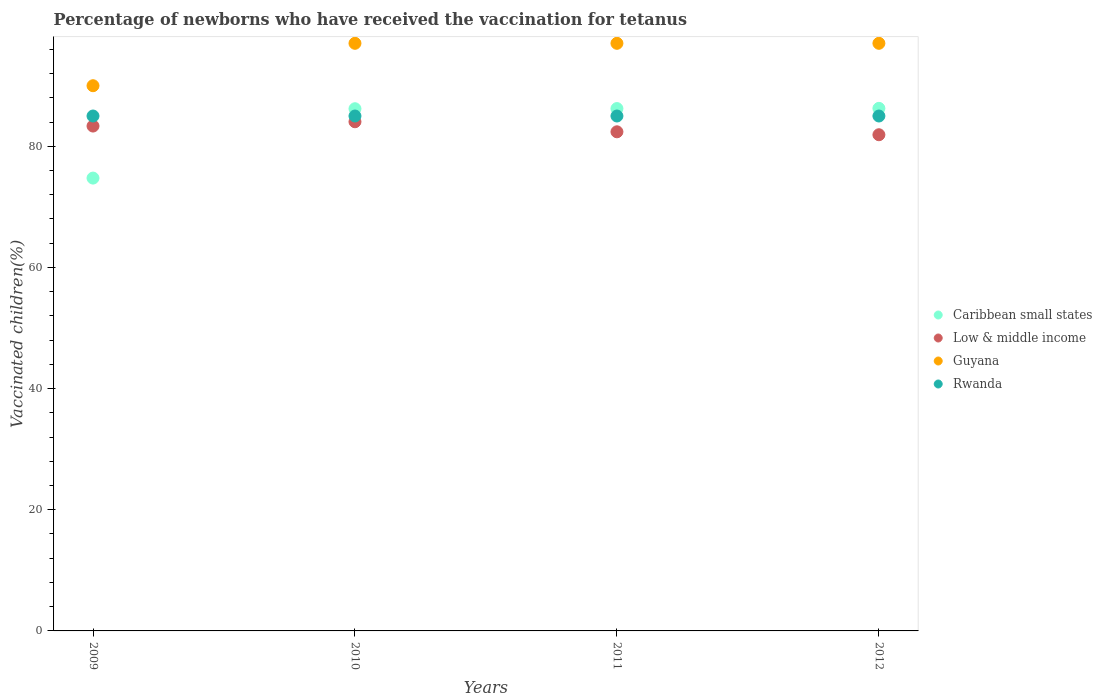Is the number of dotlines equal to the number of legend labels?
Your answer should be compact. Yes. What is the percentage of vaccinated children in Low & middle income in 2011?
Your answer should be very brief. 82.39. Across all years, what is the maximum percentage of vaccinated children in Guyana?
Keep it short and to the point. 97. Across all years, what is the minimum percentage of vaccinated children in Rwanda?
Give a very brief answer. 85. In which year was the percentage of vaccinated children in Caribbean small states maximum?
Your answer should be compact. 2012. What is the total percentage of vaccinated children in Caribbean small states in the graph?
Give a very brief answer. 333.44. What is the difference between the percentage of vaccinated children in Caribbean small states in 2009 and that in 2011?
Give a very brief answer. -11.47. What is the difference between the percentage of vaccinated children in Low & middle income in 2010 and the percentage of vaccinated children in Rwanda in 2009?
Keep it short and to the point. -0.95. What is the average percentage of vaccinated children in Caribbean small states per year?
Your answer should be compact. 83.36. In the year 2009, what is the difference between the percentage of vaccinated children in Rwanda and percentage of vaccinated children in Low & middle income?
Make the answer very short. 1.66. In how many years, is the percentage of vaccinated children in Guyana greater than 92 %?
Offer a terse response. 3. What is the ratio of the percentage of vaccinated children in Low & middle income in 2010 to that in 2012?
Provide a short and direct response. 1.03. Is the difference between the percentage of vaccinated children in Rwanda in 2010 and 2012 greater than the difference between the percentage of vaccinated children in Low & middle income in 2010 and 2012?
Your answer should be very brief. No. What is the difference between the highest and the second highest percentage of vaccinated children in Low & middle income?
Make the answer very short. 0.71. In how many years, is the percentage of vaccinated children in Rwanda greater than the average percentage of vaccinated children in Rwanda taken over all years?
Offer a very short reply. 0. Is the sum of the percentage of vaccinated children in Rwanda in 2009 and 2011 greater than the maximum percentage of vaccinated children in Low & middle income across all years?
Offer a terse response. Yes. Is it the case that in every year, the sum of the percentage of vaccinated children in Caribbean small states and percentage of vaccinated children in Rwanda  is greater than the sum of percentage of vaccinated children in Guyana and percentage of vaccinated children in Low & middle income?
Ensure brevity in your answer.  No. Is the percentage of vaccinated children in Low & middle income strictly greater than the percentage of vaccinated children in Rwanda over the years?
Keep it short and to the point. No. How many years are there in the graph?
Your response must be concise. 4. Where does the legend appear in the graph?
Your response must be concise. Center right. What is the title of the graph?
Your answer should be very brief. Percentage of newborns who have received the vaccination for tetanus. Does "Cambodia" appear as one of the legend labels in the graph?
Offer a very short reply. No. What is the label or title of the X-axis?
Offer a very short reply. Years. What is the label or title of the Y-axis?
Offer a very short reply. Vaccinated children(%). What is the Vaccinated children(%) in Caribbean small states in 2009?
Ensure brevity in your answer.  74.75. What is the Vaccinated children(%) in Low & middle income in 2009?
Offer a very short reply. 83.34. What is the Vaccinated children(%) of Guyana in 2009?
Make the answer very short. 90. What is the Vaccinated children(%) in Rwanda in 2009?
Your response must be concise. 85. What is the Vaccinated children(%) in Caribbean small states in 2010?
Give a very brief answer. 86.2. What is the Vaccinated children(%) of Low & middle income in 2010?
Make the answer very short. 84.05. What is the Vaccinated children(%) of Guyana in 2010?
Your answer should be very brief. 97. What is the Vaccinated children(%) in Caribbean small states in 2011?
Your answer should be compact. 86.23. What is the Vaccinated children(%) of Low & middle income in 2011?
Your response must be concise. 82.39. What is the Vaccinated children(%) in Guyana in 2011?
Ensure brevity in your answer.  97. What is the Vaccinated children(%) of Caribbean small states in 2012?
Your answer should be compact. 86.26. What is the Vaccinated children(%) of Low & middle income in 2012?
Ensure brevity in your answer.  81.91. What is the Vaccinated children(%) of Guyana in 2012?
Provide a short and direct response. 97. What is the Vaccinated children(%) of Rwanda in 2012?
Keep it short and to the point. 85. Across all years, what is the maximum Vaccinated children(%) in Caribbean small states?
Provide a succinct answer. 86.26. Across all years, what is the maximum Vaccinated children(%) in Low & middle income?
Make the answer very short. 84.05. Across all years, what is the maximum Vaccinated children(%) in Guyana?
Your answer should be compact. 97. Across all years, what is the maximum Vaccinated children(%) in Rwanda?
Provide a succinct answer. 85. Across all years, what is the minimum Vaccinated children(%) of Caribbean small states?
Your answer should be compact. 74.75. Across all years, what is the minimum Vaccinated children(%) in Low & middle income?
Provide a short and direct response. 81.91. Across all years, what is the minimum Vaccinated children(%) in Rwanda?
Your answer should be very brief. 85. What is the total Vaccinated children(%) of Caribbean small states in the graph?
Offer a very short reply. 333.44. What is the total Vaccinated children(%) in Low & middle income in the graph?
Give a very brief answer. 331.69. What is the total Vaccinated children(%) of Guyana in the graph?
Ensure brevity in your answer.  381. What is the total Vaccinated children(%) in Rwanda in the graph?
Give a very brief answer. 340. What is the difference between the Vaccinated children(%) in Caribbean small states in 2009 and that in 2010?
Your response must be concise. -11.45. What is the difference between the Vaccinated children(%) in Low & middle income in 2009 and that in 2010?
Your answer should be very brief. -0.71. What is the difference between the Vaccinated children(%) in Guyana in 2009 and that in 2010?
Keep it short and to the point. -7. What is the difference between the Vaccinated children(%) of Rwanda in 2009 and that in 2010?
Provide a short and direct response. 0. What is the difference between the Vaccinated children(%) of Caribbean small states in 2009 and that in 2011?
Your response must be concise. -11.47. What is the difference between the Vaccinated children(%) of Low & middle income in 2009 and that in 2011?
Provide a short and direct response. 0.95. What is the difference between the Vaccinated children(%) of Guyana in 2009 and that in 2011?
Your response must be concise. -7. What is the difference between the Vaccinated children(%) in Rwanda in 2009 and that in 2011?
Ensure brevity in your answer.  0. What is the difference between the Vaccinated children(%) in Caribbean small states in 2009 and that in 2012?
Provide a short and direct response. -11.51. What is the difference between the Vaccinated children(%) in Low & middle income in 2009 and that in 2012?
Make the answer very short. 1.43. What is the difference between the Vaccinated children(%) in Guyana in 2009 and that in 2012?
Keep it short and to the point. -7. What is the difference between the Vaccinated children(%) in Caribbean small states in 2010 and that in 2011?
Keep it short and to the point. -0.03. What is the difference between the Vaccinated children(%) of Low & middle income in 2010 and that in 2011?
Ensure brevity in your answer.  1.66. What is the difference between the Vaccinated children(%) of Guyana in 2010 and that in 2011?
Make the answer very short. 0. What is the difference between the Vaccinated children(%) in Rwanda in 2010 and that in 2011?
Give a very brief answer. 0. What is the difference between the Vaccinated children(%) in Caribbean small states in 2010 and that in 2012?
Offer a terse response. -0.06. What is the difference between the Vaccinated children(%) in Low & middle income in 2010 and that in 2012?
Your answer should be very brief. 2.14. What is the difference between the Vaccinated children(%) in Rwanda in 2010 and that in 2012?
Provide a succinct answer. 0. What is the difference between the Vaccinated children(%) of Caribbean small states in 2011 and that in 2012?
Your answer should be compact. -0.03. What is the difference between the Vaccinated children(%) of Low & middle income in 2011 and that in 2012?
Keep it short and to the point. 0.48. What is the difference between the Vaccinated children(%) of Guyana in 2011 and that in 2012?
Offer a very short reply. 0. What is the difference between the Vaccinated children(%) of Rwanda in 2011 and that in 2012?
Keep it short and to the point. 0. What is the difference between the Vaccinated children(%) of Caribbean small states in 2009 and the Vaccinated children(%) of Low & middle income in 2010?
Provide a short and direct response. -9.3. What is the difference between the Vaccinated children(%) of Caribbean small states in 2009 and the Vaccinated children(%) of Guyana in 2010?
Offer a terse response. -22.25. What is the difference between the Vaccinated children(%) of Caribbean small states in 2009 and the Vaccinated children(%) of Rwanda in 2010?
Your answer should be compact. -10.25. What is the difference between the Vaccinated children(%) of Low & middle income in 2009 and the Vaccinated children(%) of Guyana in 2010?
Offer a very short reply. -13.66. What is the difference between the Vaccinated children(%) of Low & middle income in 2009 and the Vaccinated children(%) of Rwanda in 2010?
Offer a very short reply. -1.66. What is the difference between the Vaccinated children(%) in Guyana in 2009 and the Vaccinated children(%) in Rwanda in 2010?
Keep it short and to the point. 5. What is the difference between the Vaccinated children(%) of Caribbean small states in 2009 and the Vaccinated children(%) of Low & middle income in 2011?
Your response must be concise. -7.64. What is the difference between the Vaccinated children(%) of Caribbean small states in 2009 and the Vaccinated children(%) of Guyana in 2011?
Your answer should be compact. -22.25. What is the difference between the Vaccinated children(%) in Caribbean small states in 2009 and the Vaccinated children(%) in Rwanda in 2011?
Your answer should be very brief. -10.25. What is the difference between the Vaccinated children(%) of Low & middle income in 2009 and the Vaccinated children(%) of Guyana in 2011?
Provide a succinct answer. -13.66. What is the difference between the Vaccinated children(%) of Low & middle income in 2009 and the Vaccinated children(%) of Rwanda in 2011?
Your answer should be compact. -1.66. What is the difference between the Vaccinated children(%) of Caribbean small states in 2009 and the Vaccinated children(%) of Low & middle income in 2012?
Your response must be concise. -7.16. What is the difference between the Vaccinated children(%) of Caribbean small states in 2009 and the Vaccinated children(%) of Guyana in 2012?
Your answer should be very brief. -22.25. What is the difference between the Vaccinated children(%) in Caribbean small states in 2009 and the Vaccinated children(%) in Rwanda in 2012?
Provide a succinct answer. -10.25. What is the difference between the Vaccinated children(%) in Low & middle income in 2009 and the Vaccinated children(%) in Guyana in 2012?
Provide a succinct answer. -13.66. What is the difference between the Vaccinated children(%) of Low & middle income in 2009 and the Vaccinated children(%) of Rwanda in 2012?
Keep it short and to the point. -1.66. What is the difference between the Vaccinated children(%) in Guyana in 2009 and the Vaccinated children(%) in Rwanda in 2012?
Provide a succinct answer. 5. What is the difference between the Vaccinated children(%) in Caribbean small states in 2010 and the Vaccinated children(%) in Low & middle income in 2011?
Give a very brief answer. 3.81. What is the difference between the Vaccinated children(%) of Caribbean small states in 2010 and the Vaccinated children(%) of Guyana in 2011?
Provide a succinct answer. -10.8. What is the difference between the Vaccinated children(%) in Caribbean small states in 2010 and the Vaccinated children(%) in Rwanda in 2011?
Give a very brief answer. 1.2. What is the difference between the Vaccinated children(%) in Low & middle income in 2010 and the Vaccinated children(%) in Guyana in 2011?
Make the answer very short. -12.95. What is the difference between the Vaccinated children(%) of Low & middle income in 2010 and the Vaccinated children(%) of Rwanda in 2011?
Offer a very short reply. -0.95. What is the difference between the Vaccinated children(%) of Caribbean small states in 2010 and the Vaccinated children(%) of Low & middle income in 2012?
Offer a terse response. 4.29. What is the difference between the Vaccinated children(%) of Caribbean small states in 2010 and the Vaccinated children(%) of Guyana in 2012?
Keep it short and to the point. -10.8. What is the difference between the Vaccinated children(%) of Caribbean small states in 2010 and the Vaccinated children(%) of Rwanda in 2012?
Your answer should be very brief. 1.2. What is the difference between the Vaccinated children(%) in Low & middle income in 2010 and the Vaccinated children(%) in Guyana in 2012?
Provide a succinct answer. -12.95. What is the difference between the Vaccinated children(%) of Low & middle income in 2010 and the Vaccinated children(%) of Rwanda in 2012?
Keep it short and to the point. -0.95. What is the difference between the Vaccinated children(%) of Guyana in 2010 and the Vaccinated children(%) of Rwanda in 2012?
Your response must be concise. 12. What is the difference between the Vaccinated children(%) in Caribbean small states in 2011 and the Vaccinated children(%) in Low & middle income in 2012?
Give a very brief answer. 4.32. What is the difference between the Vaccinated children(%) of Caribbean small states in 2011 and the Vaccinated children(%) of Guyana in 2012?
Offer a terse response. -10.77. What is the difference between the Vaccinated children(%) in Caribbean small states in 2011 and the Vaccinated children(%) in Rwanda in 2012?
Your response must be concise. 1.23. What is the difference between the Vaccinated children(%) in Low & middle income in 2011 and the Vaccinated children(%) in Guyana in 2012?
Make the answer very short. -14.61. What is the difference between the Vaccinated children(%) of Low & middle income in 2011 and the Vaccinated children(%) of Rwanda in 2012?
Make the answer very short. -2.61. What is the average Vaccinated children(%) of Caribbean small states per year?
Offer a very short reply. 83.36. What is the average Vaccinated children(%) of Low & middle income per year?
Ensure brevity in your answer.  82.92. What is the average Vaccinated children(%) of Guyana per year?
Ensure brevity in your answer.  95.25. In the year 2009, what is the difference between the Vaccinated children(%) of Caribbean small states and Vaccinated children(%) of Low & middle income?
Give a very brief answer. -8.59. In the year 2009, what is the difference between the Vaccinated children(%) in Caribbean small states and Vaccinated children(%) in Guyana?
Ensure brevity in your answer.  -15.25. In the year 2009, what is the difference between the Vaccinated children(%) in Caribbean small states and Vaccinated children(%) in Rwanda?
Keep it short and to the point. -10.25. In the year 2009, what is the difference between the Vaccinated children(%) of Low & middle income and Vaccinated children(%) of Guyana?
Provide a short and direct response. -6.66. In the year 2009, what is the difference between the Vaccinated children(%) of Low & middle income and Vaccinated children(%) of Rwanda?
Give a very brief answer. -1.66. In the year 2009, what is the difference between the Vaccinated children(%) of Guyana and Vaccinated children(%) of Rwanda?
Keep it short and to the point. 5. In the year 2010, what is the difference between the Vaccinated children(%) in Caribbean small states and Vaccinated children(%) in Low & middle income?
Provide a short and direct response. 2.15. In the year 2010, what is the difference between the Vaccinated children(%) of Caribbean small states and Vaccinated children(%) of Guyana?
Ensure brevity in your answer.  -10.8. In the year 2010, what is the difference between the Vaccinated children(%) of Caribbean small states and Vaccinated children(%) of Rwanda?
Your answer should be very brief. 1.2. In the year 2010, what is the difference between the Vaccinated children(%) in Low & middle income and Vaccinated children(%) in Guyana?
Your answer should be very brief. -12.95. In the year 2010, what is the difference between the Vaccinated children(%) of Low & middle income and Vaccinated children(%) of Rwanda?
Your answer should be very brief. -0.95. In the year 2011, what is the difference between the Vaccinated children(%) in Caribbean small states and Vaccinated children(%) in Low & middle income?
Provide a short and direct response. 3.83. In the year 2011, what is the difference between the Vaccinated children(%) in Caribbean small states and Vaccinated children(%) in Guyana?
Your answer should be compact. -10.77. In the year 2011, what is the difference between the Vaccinated children(%) in Caribbean small states and Vaccinated children(%) in Rwanda?
Offer a very short reply. 1.23. In the year 2011, what is the difference between the Vaccinated children(%) in Low & middle income and Vaccinated children(%) in Guyana?
Make the answer very short. -14.61. In the year 2011, what is the difference between the Vaccinated children(%) in Low & middle income and Vaccinated children(%) in Rwanda?
Ensure brevity in your answer.  -2.61. In the year 2011, what is the difference between the Vaccinated children(%) of Guyana and Vaccinated children(%) of Rwanda?
Provide a short and direct response. 12. In the year 2012, what is the difference between the Vaccinated children(%) in Caribbean small states and Vaccinated children(%) in Low & middle income?
Your response must be concise. 4.35. In the year 2012, what is the difference between the Vaccinated children(%) of Caribbean small states and Vaccinated children(%) of Guyana?
Your answer should be very brief. -10.74. In the year 2012, what is the difference between the Vaccinated children(%) of Caribbean small states and Vaccinated children(%) of Rwanda?
Offer a very short reply. 1.26. In the year 2012, what is the difference between the Vaccinated children(%) of Low & middle income and Vaccinated children(%) of Guyana?
Give a very brief answer. -15.09. In the year 2012, what is the difference between the Vaccinated children(%) in Low & middle income and Vaccinated children(%) in Rwanda?
Your response must be concise. -3.09. What is the ratio of the Vaccinated children(%) in Caribbean small states in 2009 to that in 2010?
Offer a terse response. 0.87. What is the ratio of the Vaccinated children(%) in Guyana in 2009 to that in 2010?
Your answer should be compact. 0.93. What is the ratio of the Vaccinated children(%) of Rwanda in 2009 to that in 2010?
Your answer should be compact. 1. What is the ratio of the Vaccinated children(%) of Caribbean small states in 2009 to that in 2011?
Offer a very short reply. 0.87. What is the ratio of the Vaccinated children(%) in Low & middle income in 2009 to that in 2011?
Give a very brief answer. 1.01. What is the ratio of the Vaccinated children(%) of Guyana in 2009 to that in 2011?
Your answer should be very brief. 0.93. What is the ratio of the Vaccinated children(%) in Rwanda in 2009 to that in 2011?
Your answer should be compact. 1. What is the ratio of the Vaccinated children(%) of Caribbean small states in 2009 to that in 2012?
Your response must be concise. 0.87. What is the ratio of the Vaccinated children(%) of Low & middle income in 2009 to that in 2012?
Your answer should be very brief. 1.02. What is the ratio of the Vaccinated children(%) in Guyana in 2009 to that in 2012?
Provide a succinct answer. 0.93. What is the ratio of the Vaccinated children(%) of Low & middle income in 2010 to that in 2011?
Provide a short and direct response. 1.02. What is the ratio of the Vaccinated children(%) in Guyana in 2010 to that in 2011?
Your response must be concise. 1. What is the ratio of the Vaccinated children(%) of Rwanda in 2010 to that in 2011?
Your response must be concise. 1. What is the ratio of the Vaccinated children(%) of Low & middle income in 2010 to that in 2012?
Provide a succinct answer. 1.03. What is the ratio of the Vaccinated children(%) in Low & middle income in 2011 to that in 2012?
Provide a succinct answer. 1.01. What is the ratio of the Vaccinated children(%) in Rwanda in 2011 to that in 2012?
Keep it short and to the point. 1. What is the difference between the highest and the second highest Vaccinated children(%) in Caribbean small states?
Make the answer very short. 0.03. What is the difference between the highest and the second highest Vaccinated children(%) of Low & middle income?
Give a very brief answer. 0.71. What is the difference between the highest and the second highest Vaccinated children(%) in Rwanda?
Your answer should be compact. 0. What is the difference between the highest and the lowest Vaccinated children(%) of Caribbean small states?
Keep it short and to the point. 11.51. What is the difference between the highest and the lowest Vaccinated children(%) in Low & middle income?
Your answer should be compact. 2.14. What is the difference between the highest and the lowest Vaccinated children(%) of Guyana?
Your answer should be compact. 7. What is the difference between the highest and the lowest Vaccinated children(%) of Rwanda?
Ensure brevity in your answer.  0. 